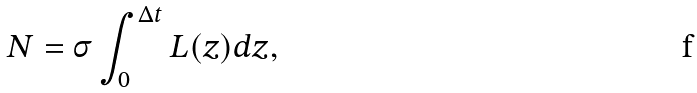<formula> <loc_0><loc_0><loc_500><loc_500>N = \sigma \int _ { 0 } ^ { \Delta t } L ( z ) d z ,</formula> 